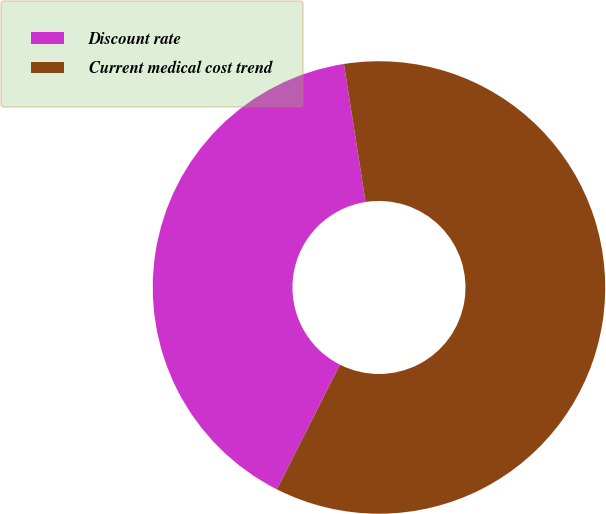Convert chart to OTSL. <chart><loc_0><loc_0><loc_500><loc_500><pie_chart><fcel>Discount rate<fcel>Current medical cost trend<nl><fcel>40.08%<fcel>59.92%<nl></chart> 